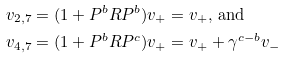Convert formula to latex. <formula><loc_0><loc_0><loc_500><loc_500>v _ { 2 , 7 } & = ( 1 + P ^ { b } R P ^ { b } ) v _ { + } = v _ { + } , \, \text {and} \\ v _ { 4 , 7 } & = ( 1 + P ^ { b } R P ^ { c } ) v _ { + } = v _ { + } + \gamma ^ { c - b } v _ { - }</formula> 